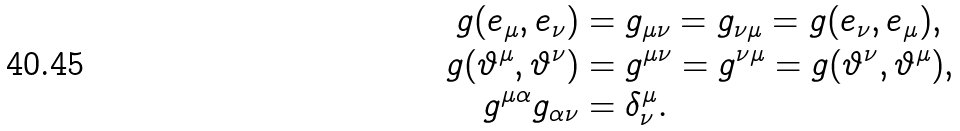<formula> <loc_0><loc_0><loc_500><loc_500>g ( e _ { \mu } , e _ { \nu } ) & = g _ { \mu \nu } = g _ { \nu \mu } = g ( e _ { \nu } , e _ { \mu } ) , \\ g ( \vartheta ^ { \mu } , \vartheta ^ { \nu } ) & = g ^ { \mu \nu } = g ^ { \nu \mu } = g ( \vartheta ^ { \nu } , \vartheta ^ { \mu } ) , \\ g ^ { \mu \alpha } g _ { \alpha \nu } & = \delta _ { \nu } ^ { \mu } .</formula> 